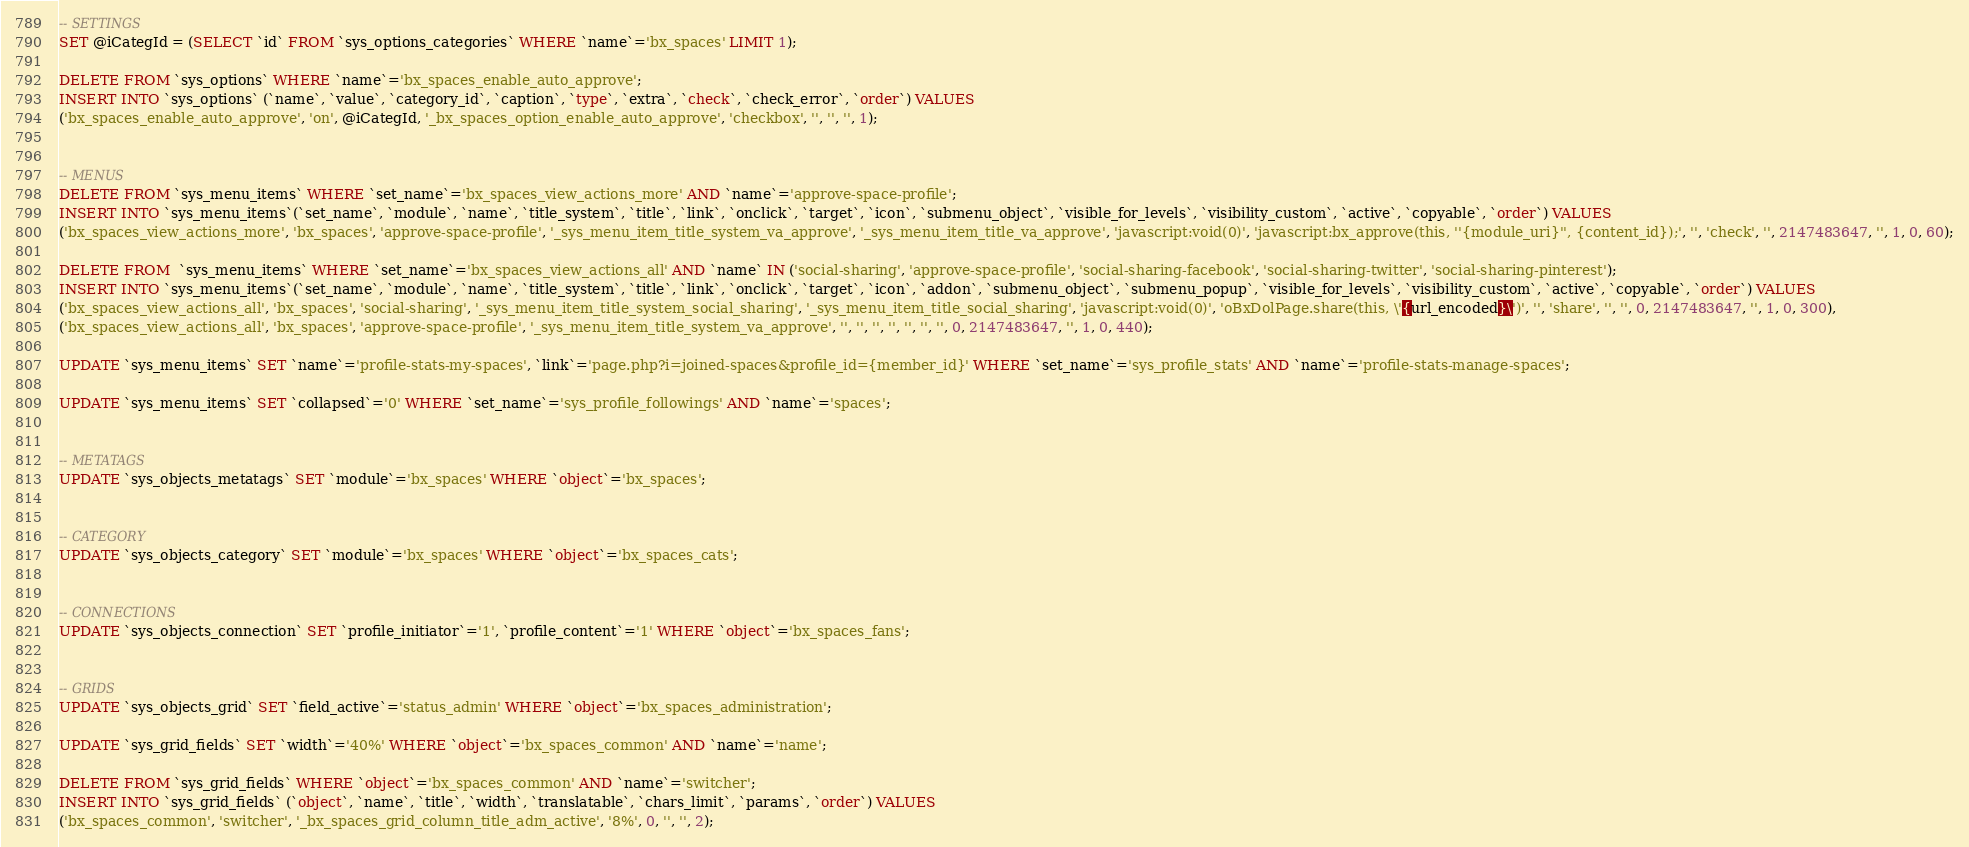Convert code to text. <code><loc_0><loc_0><loc_500><loc_500><_SQL_>-- SETTINGS
SET @iCategId = (SELECT `id` FROM `sys_options_categories` WHERE `name`='bx_spaces' LIMIT 1);

DELETE FROM `sys_options` WHERE `name`='bx_spaces_enable_auto_approve';
INSERT INTO `sys_options` (`name`, `value`, `category_id`, `caption`, `type`, `extra`, `check`, `check_error`, `order`) VALUES
('bx_spaces_enable_auto_approve', 'on', @iCategId, '_bx_spaces_option_enable_auto_approve', 'checkbox', '', '', '', 1);


-- MENUS
DELETE FROM `sys_menu_items` WHERE `set_name`='bx_spaces_view_actions_more' AND `name`='approve-space-profile';
INSERT INTO `sys_menu_items`(`set_name`, `module`, `name`, `title_system`, `title`, `link`, `onclick`, `target`, `icon`, `submenu_object`, `visible_for_levels`, `visibility_custom`, `active`, `copyable`, `order`) VALUES 
('bx_spaces_view_actions_more', 'bx_spaces', 'approve-space-profile', '_sys_menu_item_title_system_va_approve', '_sys_menu_item_title_va_approve', 'javascript:void(0)', 'javascript:bx_approve(this, ''{module_uri}'', {content_id});', '', 'check', '', 2147483647, '', 1, 0, 60);

DELETE FROM  `sys_menu_items` WHERE `set_name`='bx_spaces_view_actions_all' AND `name` IN ('social-sharing', 'approve-space-profile', 'social-sharing-facebook', 'social-sharing-twitter', 'social-sharing-pinterest');
INSERT INTO `sys_menu_items`(`set_name`, `module`, `name`, `title_system`, `title`, `link`, `onclick`, `target`, `icon`, `addon`, `submenu_object`, `submenu_popup`, `visible_for_levels`, `visibility_custom`, `active`, `copyable`, `order`) VALUES 
('bx_spaces_view_actions_all', 'bx_spaces', 'social-sharing', '_sys_menu_item_title_system_social_sharing', '_sys_menu_item_title_social_sharing', 'javascript:void(0)', 'oBxDolPage.share(this, \'{url_encoded}\')', '', 'share', '', '', 0, 2147483647, '', 1, 0, 300),
('bx_spaces_view_actions_all', 'bx_spaces', 'approve-space-profile', '_sys_menu_item_title_system_va_approve', '', '', '', '', '', '', '', 0, 2147483647, '', 1, 0, 440);

UPDATE `sys_menu_items` SET `name`='profile-stats-my-spaces', `link`='page.php?i=joined-spaces&profile_id={member_id}' WHERE `set_name`='sys_profile_stats' AND `name`='profile-stats-manage-spaces';

UPDATE `sys_menu_items` SET `collapsed`='0' WHERE `set_name`='sys_profile_followings' AND `name`='spaces';


-- METATAGS
UPDATE `sys_objects_metatags` SET `module`='bx_spaces' WHERE `object`='bx_spaces';


-- CATEGORY
UPDATE `sys_objects_category` SET `module`='bx_spaces' WHERE `object`='bx_spaces_cats';


-- CONNECTIONS
UPDATE `sys_objects_connection` SET `profile_initiator`='1', `profile_content`='1' WHERE `object`='bx_spaces_fans';


-- GRIDS
UPDATE `sys_objects_grid` SET `field_active`='status_admin' WHERE `object`='bx_spaces_administration';

UPDATE `sys_grid_fields` SET `width`='40%' WHERE `object`='bx_spaces_common' AND `name`='name';

DELETE FROM `sys_grid_fields` WHERE `object`='bx_spaces_common' AND `name`='switcher';
INSERT INTO `sys_grid_fields` (`object`, `name`, `title`, `width`, `translatable`, `chars_limit`, `params`, `order`) VALUES
('bx_spaces_common', 'switcher', '_bx_spaces_grid_column_title_adm_active', '8%', 0, '', '', 2);
</code> 